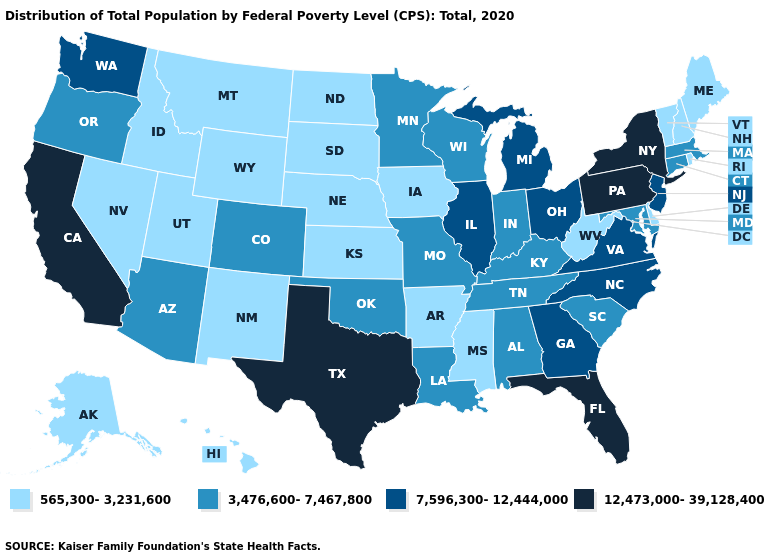What is the highest value in states that border Indiana?
Quick response, please. 7,596,300-12,444,000. Does Kansas have the lowest value in the MidWest?
Keep it brief. Yes. Name the states that have a value in the range 7,596,300-12,444,000?
Quick response, please. Georgia, Illinois, Michigan, New Jersey, North Carolina, Ohio, Virginia, Washington. Among the states that border Illinois , does Indiana have the lowest value?
Write a very short answer. No. Does New York have the same value as Pennsylvania?
Give a very brief answer. Yes. Does Idaho have the lowest value in the USA?
Be succinct. Yes. Does West Virginia have the lowest value in the South?
Short answer required. Yes. Name the states that have a value in the range 12,473,000-39,128,400?
Short answer required. California, Florida, New York, Pennsylvania, Texas. Among the states that border Minnesota , which have the highest value?
Write a very short answer. Wisconsin. Does California have the highest value in the West?
Answer briefly. Yes. Name the states that have a value in the range 565,300-3,231,600?
Keep it brief. Alaska, Arkansas, Delaware, Hawaii, Idaho, Iowa, Kansas, Maine, Mississippi, Montana, Nebraska, Nevada, New Hampshire, New Mexico, North Dakota, Rhode Island, South Dakota, Utah, Vermont, West Virginia, Wyoming. Does West Virginia have the same value as Arizona?
Concise answer only. No. What is the value of Indiana?
Answer briefly. 3,476,600-7,467,800. Does Pennsylvania have the same value as Idaho?
Quick response, please. No. How many symbols are there in the legend?
Be succinct. 4. 